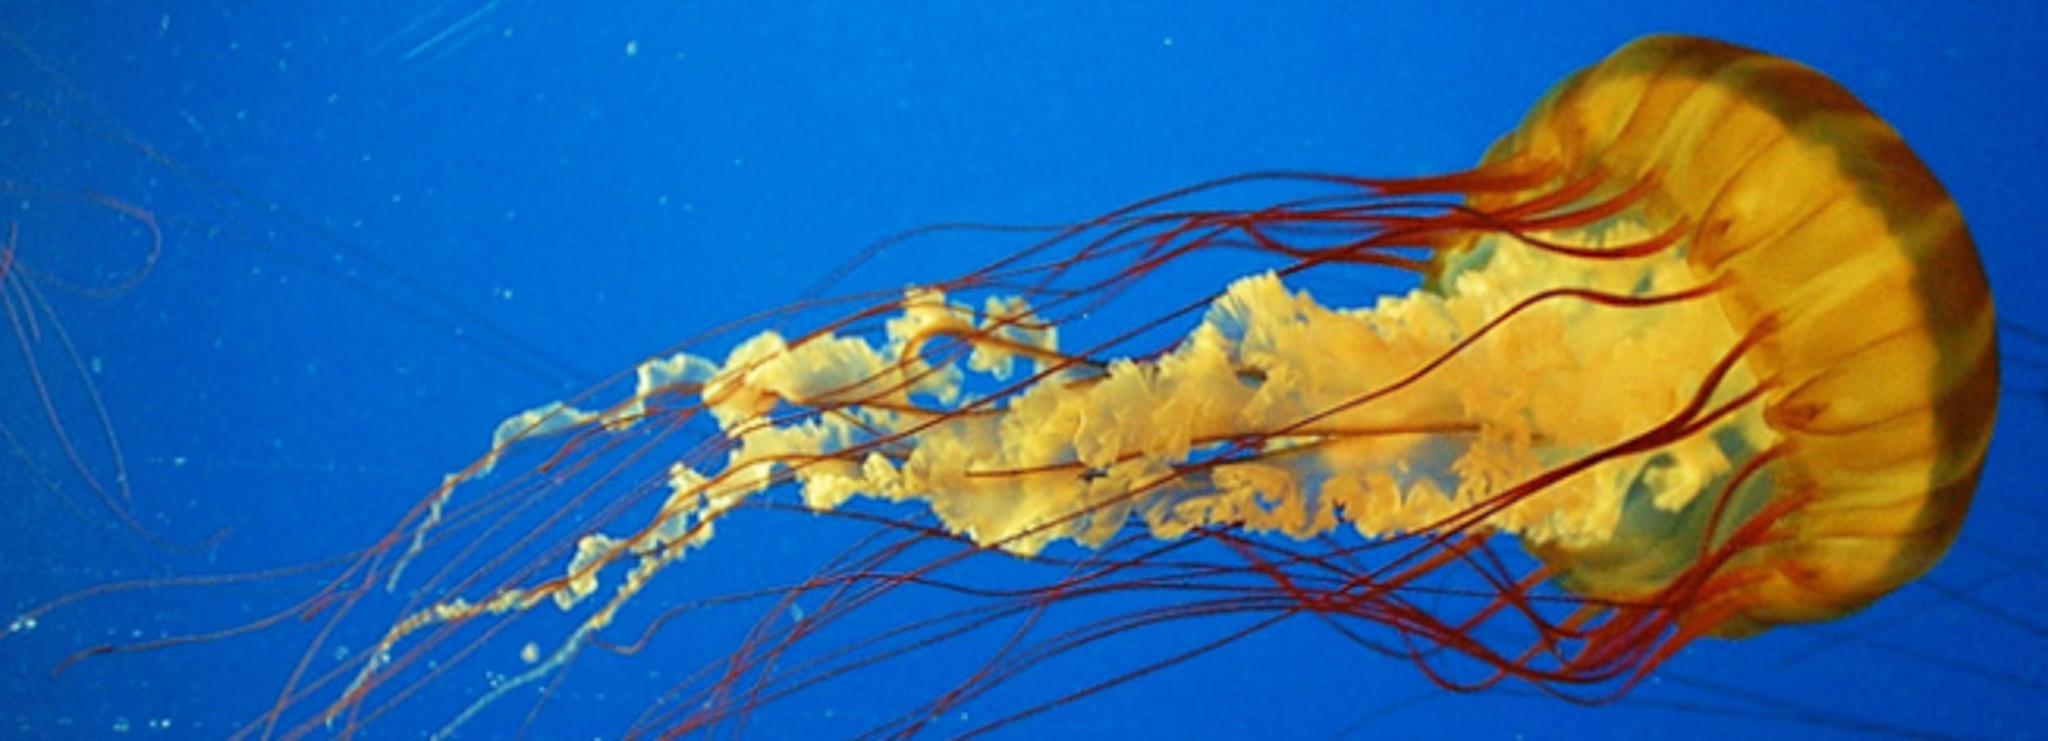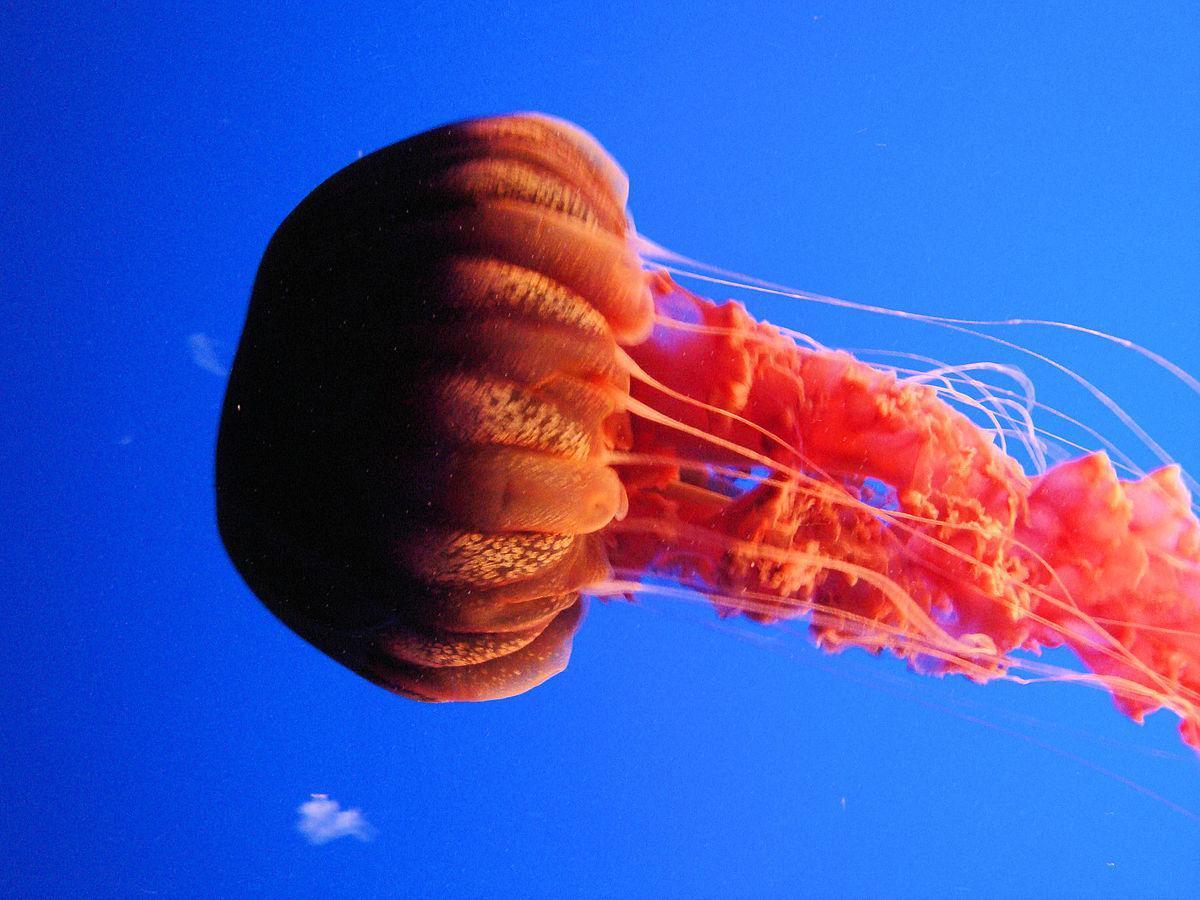The first image is the image on the left, the second image is the image on the right. Examine the images to the left and right. Is the description "Both images contain a single jellyfish." accurate? Answer yes or no. Yes. 